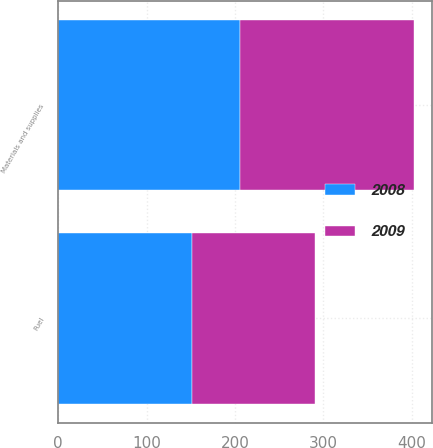Convert chart. <chart><loc_0><loc_0><loc_500><loc_500><stacked_bar_chart><ecel><fcel>Fuel<fcel>Materials and supplies<nl><fcel>2008<fcel>151<fcel>206<nl><fcel>2009<fcel>140<fcel>197<nl></chart> 